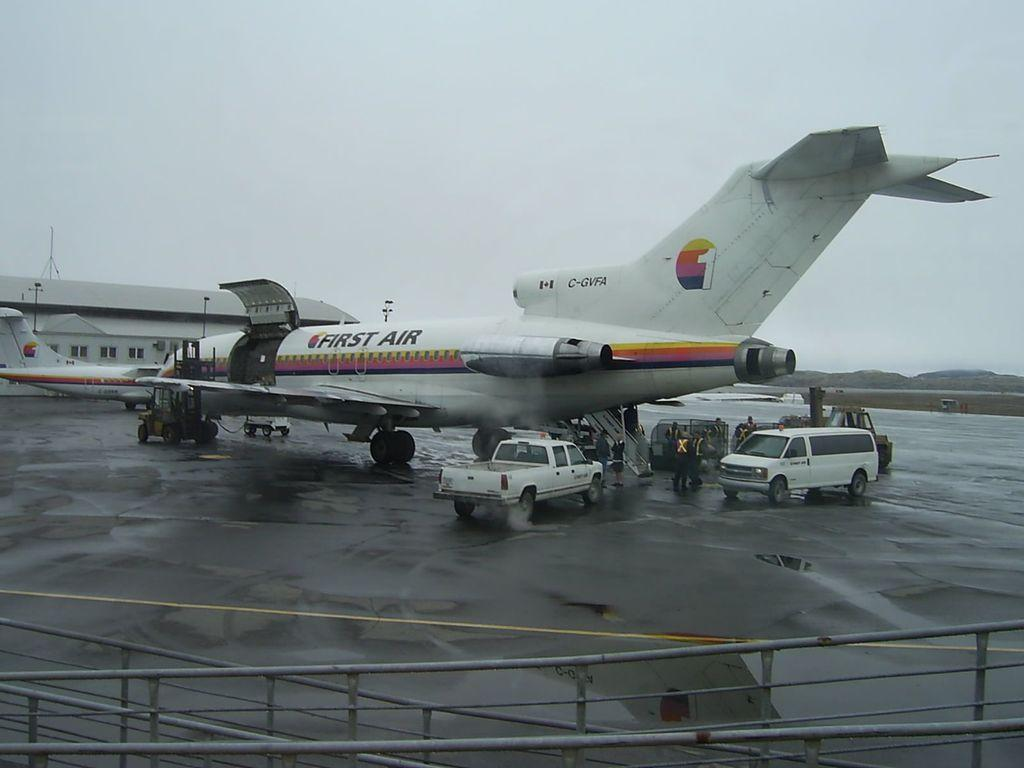What is the main subject of the image? The main subject of the image is an aeroplane. What color is the aeroplane? The aeroplane is white in color. What else can be seen in the image besides the aeroplane? There are two vehicles on the road. How would you describe the sky in the image? The sky is cloudy. How many boats can be seen on the roof in the image? There are no boats or roofs present in the image; it features an aeroplane, two vehicles on the road, and a cloudy sky. --- Facts: 1. There is a person sitting on a bench. 2. The person is reading a book. 3. There is a tree behind the bench. 4. The ground is covered in grass. Absurd Topics: parrot, sand, bicycle Conversation: What is the person in the image doing? The person is sitting on a bench and reading a book. What can be seen behind the bench in the image? There is a tree behind the bench. What type of surface is the person sitting on? The ground is covered in grass. Reasoning: Let's think step by step in order to produce the conversation. We start by identifying the main subject of the image, which is the person sitting on a bench. Then, we describe the person's activity, which is reading a book. Next, we mention the presence of a tree behind the bench to acknowledge other elements in the image. Finally, we describe the ground's surface, which is covered in grass, to give a sense of the environment. Absurd Question/Answer: Can you tell me how many parrots are sitting on the bicycle in the image? There are no parrots or bicycles present in the image; it features a person sitting on a bench, reading a book, with a tree behind the bench and grass-covered ground. 